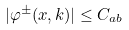Convert formula to latex. <formula><loc_0><loc_0><loc_500><loc_500>| \varphi ^ { \pm } ( x , k ) | \leq C _ { a b }</formula> 